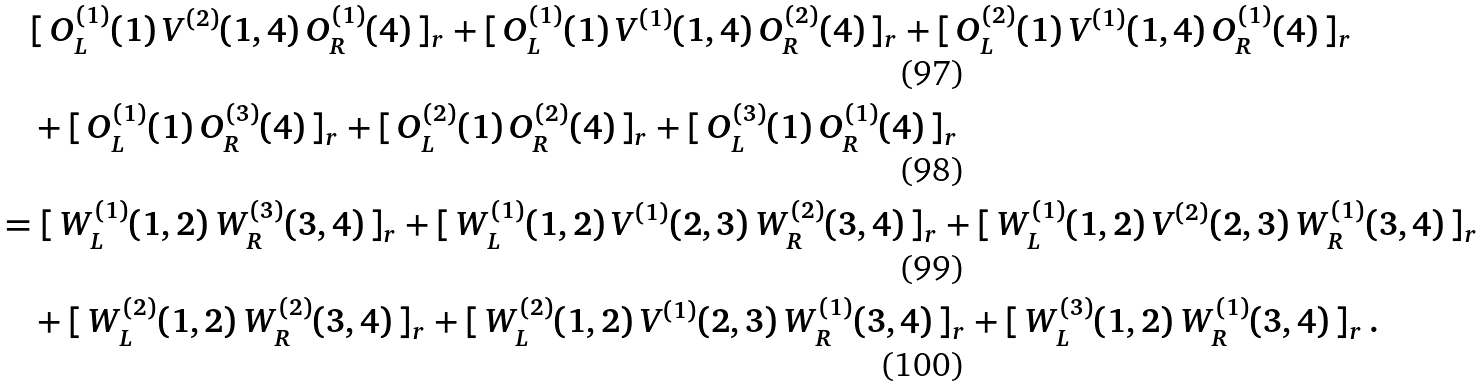<formula> <loc_0><loc_0><loc_500><loc_500>& \quad [ \, O _ { L } ^ { ( 1 ) } ( 1 ) \, V ^ { ( 2 ) } ( 1 , 4 ) \, O _ { R } ^ { ( 1 ) } ( 4 ) \, ] _ { r } + [ \, O _ { L } ^ { ( 1 ) } ( 1 ) \, V ^ { ( 1 ) } ( 1 , 4 ) \, O _ { R } ^ { ( 2 ) } ( 4 ) \, ] _ { r } + [ \, O _ { L } ^ { ( 2 ) } ( 1 ) \, V ^ { ( 1 ) } ( 1 , 4 ) \, O _ { R } ^ { ( 1 ) } ( 4 ) \, ] _ { r } \\ & \quad + [ \, O _ { L } ^ { ( 1 ) } ( 1 ) \, O _ { R } ^ { ( 3 ) } ( 4 ) \, ] _ { r } + [ \, O _ { L } ^ { ( 2 ) } ( 1 ) \, O _ { R } ^ { ( 2 ) } ( 4 ) \, ] _ { r } + [ \, O _ { L } ^ { ( 3 ) } ( 1 ) \, O _ { R } ^ { ( 1 ) } ( 4 ) \, ] _ { r } \\ & = [ \, W _ { L } ^ { ( 1 ) } ( 1 , 2 ) \, W _ { R } ^ { ( 3 ) } ( 3 , 4 ) \, ] _ { r } + [ \, W _ { L } ^ { ( 1 ) } ( 1 , 2 ) \, V ^ { ( 1 ) } ( 2 , 3 ) \, W _ { R } ^ { ( 2 ) } ( 3 , 4 ) \, ] _ { r } + [ \, W _ { L } ^ { ( 1 ) } ( 1 , 2 ) \, V ^ { ( 2 ) } ( 2 , 3 ) \, W _ { R } ^ { ( 1 ) } ( 3 , 4 ) \, ] _ { r } \\ & \quad + [ \, W _ { L } ^ { ( 2 ) } ( 1 , 2 ) \, W _ { R } ^ { ( 2 ) } ( 3 , 4 ) \, ] _ { r } + [ \, W _ { L } ^ { ( 2 ) } ( 1 , 2 ) \, V ^ { ( 1 ) } ( 2 , 3 ) \, W _ { R } ^ { ( 1 ) } ( 3 , 4 ) \, ] _ { r } + [ \, W _ { L } ^ { ( 3 ) } ( 1 , 2 ) \, W _ { R } ^ { ( 1 ) } ( 3 , 4 ) \, ] _ { r } \, .</formula> 